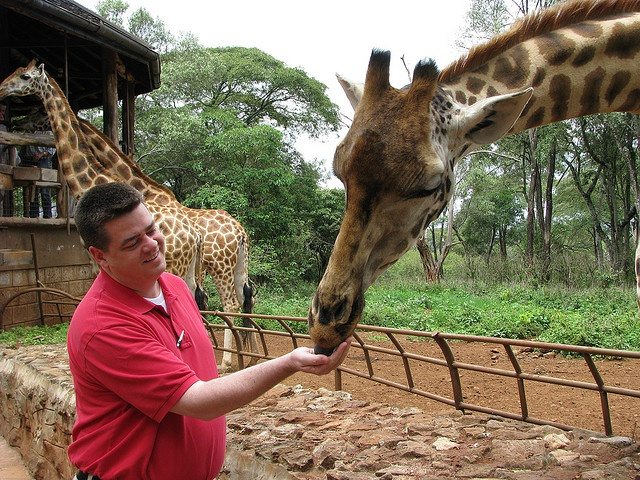Describe the objects in this image and their specific colors. I can see giraffe in black, maroon, and gray tones, people in black, maroon, brown, and salmon tones, giraffe in black, gray, tan, olive, and maroon tones, and giraffe in black, maroon, tan, and gray tones in this image. 